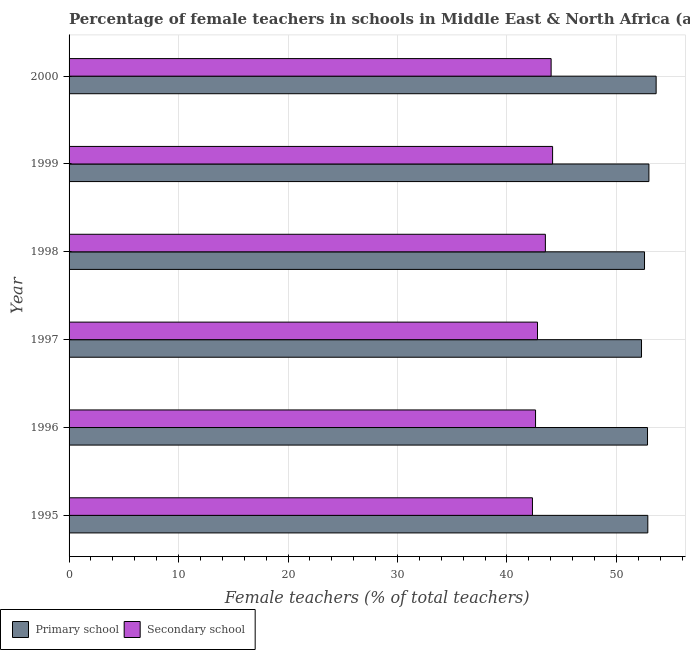Are the number of bars on each tick of the Y-axis equal?
Your answer should be very brief. Yes. What is the label of the 2nd group of bars from the top?
Keep it short and to the point. 1999. In how many cases, is the number of bars for a given year not equal to the number of legend labels?
Provide a short and direct response. 0. What is the percentage of female teachers in secondary schools in 1998?
Keep it short and to the point. 43.51. Across all years, what is the maximum percentage of female teachers in secondary schools?
Ensure brevity in your answer.  44.17. Across all years, what is the minimum percentage of female teachers in primary schools?
Offer a terse response. 52.29. What is the total percentage of female teachers in secondary schools in the graph?
Ensure brevity in your answer.  259.44. What is the difference between the percentage of female teachers in secondary schools in 1996 and that in 2000?
Make the answer very short. -1.42. What is the difference between the percentage of female teachers in primary schools in 1995 and the percentage of female teachers in secondary schools in 1999?
Provide a short and direct response. 8.7. What is the average percentage of female teachers in primary schools per year?
Provide a succinct answer. 52.86. In the year 2000, what is the difference between the percentage of female teachers in primary schools and percentage of female teachers in secondary schools?
Provide a succinct answer. 9.59. Is the difference between the percentage of female teachers in secondary schools in 1998 and 2000 greater than the difference between the percentage of female teachers in primary schools in 1998 and 2000?
Offer a terse response. Yes. What is the difference between the highest and the second highest percentage of female teachers in secondary schools?
Offer a very short reply. 0.13. What is the difference between the highest and the lowest percentage of female teachers in secondary schools?
Give a very brief answer. 1.84. In how many years, is the percentage of female teachers in primary schools greater than the average percentage of female teachers in primary schools taken over all years?
Your answer should be very brief. 3. Is the sum of the percentage of female teachers in primary schools in 1995 and 1997 greater than the maximum percentage of female teachers in secondary schools across all years?
Offer a very short reply. Yes. What does the 1st bar from the top in 1996 represents?
Offer a very short reply. Secondary school. What does the 2nd bar from the bottom in 1999 represents?
Offer a terse response. Secondary school. What is the difference between two consecutive major ticks on the X-axis?
Provide a short and direct response. 10. Does the graph contain grids?
Provide a succinct answer. Yes. What is the title of the graph?
Provide a succinct answer. Percentage of female teachers in schools in Middle East & North Africa (all income levels). What is the label or title of the X-axis?
Keep it short and to the point. Female teachers (% of total teachers). What is the label or title of the Y-axis?
Give a very brief answer. Year. What is the Female teachers (% of total teachers) of Primary school in 1995?
Give a very brief answer. 52.87. What is the Female teachers (% of total teachers) in Secondary school in 1995?
Offer a terse response. 42.33. What is the Female teachers (% of total teachers) in Primary school in 1996?
Provide a short and direct response. 52.84. What is the Female teachers (% of total teachers) in Secondary school in 1996?
Make the answer very short. 42.61. What is the Female teachers (% of total teachers) of Primary school in 1997?
Give a very brief answer. 52.29. What is the Female teachers (% of total teachers) in Secondary school in 1997?
Your answer should be very brief. 42.79. What is the Female teachers (% of total teachers) of Primary school in 1998?
Give a very brief answer. 52.56. What is the Female teachers (% of total teachers) of Secondary school in 1998?
Give a very brief answer. 43.51. What is the Female teachers (% of total teachers) of Primary school in 1999?
Make the answer very short. 52.97. What is the Female teachers (% of total teachers) of Secondary school in 1999?
Provide a short and direct response. 44.17. What is the Female teachers (% of total teachers) of Primary school in 2000?
Give a very brief answer. 53.63. What is the Female teachers (% of total teachers) of Secondary school in 2000?
Offer a very short reply. 44.03. Across all years, what is the maximum Female teachers (% of total teachers) of Primary school?
Ensure brevity in your answer.  53.63. Across all years, what is the maximum Female teachers (% of total teachers) in Secondary school?
Your response must be concise. 44.17. Across all years, what is the minimum Female teachers (% of total teachers) in Primary school?
Your answer should be compact. 52.29. Across all years, what is the minimum Female teachers (% of total teachers) of Secondary school?
Provide a short and direct response. 42.33. What is the total Female teachers (% of total teachers) in Primary school in the graph?
Your answer should be very brief. 317.15. What is the total Female teachers (% of total teachers) of Secondary school in the graph?
Offer a very short reply. 259.44. What is the difference between the Female teachers (% of total teachers) of Primary school in 1995 and that in 1996?
Ensure brevity in your answer.  0.03. What is the difference between the Female teachers (% of total teachers) of Secondary school in 1995 and that in 1996?
Your answer should be compact. -0.28. What is the difference between the Female teachers (% of total teachers) of Primary school in 1995 and that in 1997?
Offer a terse response. 0.58. What is the difference between the Female teachers (% of total teachers) of Secondary school in 1995 and that in 1997?
Your answer should be very brief. -0.46. What is the difference between the Female teachers (% of total teachers) of Primary school in 1995 and that in 1998?
Keep it short and to the point. 0.3. What is the difference between the Female teachers (% of total teachers) of Secondary school in 1995 and that in 1998?
Give a very brief answer. -1.18. What is the difference between the Female teachers (% of total teachers) in Primary school in 1995 and that in 1999?
Provide a short and direct response. -0.1. What is the difference between the Female teachers (% of total teachers) of Secondary school in 1995 and that in 1999?
Provide a succinct answer. -1.84. What is the difference between the Female teachers (% of total teachers) in Primary school in 1995 and that in 2000?
Your answer should be very brief. -0.76. What is the difference between the Female teachers (% of total teachers) of Secondary school in 1995 and that in 2000?
Offer a very short reply. -1.71. What is the difference between the Female teachers (% of total teachers) in Primary school in 1996 and that in 1997?
Make the answer very short. 0.55. What is the difference between the Female teachers (% of total teachers) in Secondary school in 1996 and that in 1997?
Keep it short and to the point. -0.18. What is the difference between the Female teachers (% of total teachers) in Primary school in 1996 and that in 1998?
Your answer should be compact. 0.27. What is the difference between the Female teachers (% of total teachers) of Secondary school in 1996 and that in 1998?
Offer a very short reply. -0.9. What is the difference between the Female teachers (% of total teachers) in Primary school in 1996 and that in 1999?
Provide a succinct answer. -0.13. What is the difference between the Female teachers (% of total teachers) of Secondary school in 1996 and that in 1999?
Make the answer very short. -1.56. What is the difference between the Female teachers (% of total teachers) in Primary school in 1996 and that in 2000?
Ensure brevity in your answer.  -0.79. What is the difference between the Female teachers (% of total teachers) of Secondary school in 1996 and that in 2000?
Your answer should be very brief. -1.42. What is the difference between the Female teachers (% of total teachers) in Primary school in 1997 and that in 1998?
Offer a very short reply. -0.27. What is the difference between the Female teachers (% of total teachers) in Secondary school in 1997 and that in 1998?
Offer a very short reply. -0.72. What is the difference between the Female teachers (% of total teachers) of Primary school in 1997 and that in 1999?
Make the answer very short. -0.68. What is the difference between the Female teachers (% of total teachers) in Secondary school in 1997 and that in 1999?
Provide a short and direct response. -1.38. What is the difference between the Female teachers (% of total teachers) of Primary school in 1997 and that in 2000?
Make the answer very short. -1.34. What is the difference between the Female teachers (% of total teachers) of Secondary school in 1997 and that in 2000?
Make the answer very short. -1.24. What is the difference between the Female teachers (% of total teachers) of Primary school in 1998 and that in 1999?
Provide a succinct answer. -0.4. What is the difference between the Female teachers (% of total teachers) in Secondary school in 1998 and that in 1999?
Keep it short and to the point. -0.66. What is the difference between the Female teachers (% of total teachers) in Primary school in 1998 and that in 2000?
Keep it short and to the point. -1.06. What is the difference between the Female teachers (% of total teachers) of Secondary school in 1998 and that in 2000?
Provide a succinct answer. -0.53. What is the difference between the Female teachers (% of total teachers) of Primary school in 1999 and that in 2000?
Your answer should be compact. -0.66. What is the difference between the Female teachers (% of total teachers) in Secondary school in 1999 and that in 2000?
Keep it short and to the point. 0.13. What is the difference between the Female teachers (% of total teachers) in Primary school in 1995 and the Female teachers (% of total teachers) in Secondary school in 1996?
Make the answer very short. 10.26. What is the difference between the Female teachers (% of total teachers) in Primary school in 1995 and the Female teachers (% of total teachers) in Secondary school in 1997?
Keep it short and to the point. 10.08. What is the difference between the Female teachers (% of total teachers) of Primary school in 1995 and the Female teachers (% of total teachers) of Secondary school in 1998?
Keep it short and to the point. 9.36. What is the difference between the Female teachers (% of total teachers) in Primary school in 1995 and the Female teachers (% of total teachers) in Secondary school in 1999?
Keep it short and to the point. 8.7. What is the difference between the Female teachers (% of total teachers) in Primary school in 1995 and the Female teachers (% of total teachers) in Secondary school in 2000?
Your answer should be compact. 8.83. What is the difference between the Female teachers (% of total teachers) in Primary school in 1996 and the Female teachers (% of total teachers) in Secondary school in 1997?
Give a very brief answer. 10.05. What is the difference between the Female teachers (% of total teachers) in Primary school in 1996 and the Female teachers (% of total teachers) in Secondary school in 1998?
Your answer should be very brief. 9.33. What is the difference between the Female teachers (% of total teachers) in Primary school in 1996 and the Female teachers (% of total teachers) in Secondary school in 1999?
Offer a terse response. 8.67. What is the difference between the Female teachers (% of total teachers) of Primary school in 1996 and the Female teachers (% of total teachers) of Secondary school in 2000?
Your answer should be very brief. 8.8. What is the difference between the Female teachers (% of total teachers) of Primary school in 1997 and the Female teachers (% of total teachers) of Secondary school in 1998?
Ensure brevity in your answer.  8.78. What is the difference between the Female teachers (% of total teachers) of Primary school in 1997 and the Female teachers (% of total teachers) of Secondary school in 1999?
Offer a very short reply. 8.12. What is the difference between the Female teachers (% of total teachers) in Primary school in 1997 and the Female teachers (% of total teachers) in Secondary school in 2000?
Provide a short and direct response. 8.26. What is the difference between the Female teachers (% of total teachers) of Primary school in 1998 and the Female teachers (% of total teachers) of Secondary school in 1999?
Give a very brief answer. 8.4. What is the difference between the Female teachers (% of total teachers) of Primary school in 1998 and the Female teachers (% of total teachers) of Secondary school in 2000?
Ensure brevity in your answer.  8.53. What is the difference between the Female teachers (% of total teachers) in Primary school in 1999 and the Female teachers (% of total teachers) in Secondary school in 2000?
Provide a short and direct response. 8.93. What is the average Female teachers (% of total teachers) of Primary school per year?
Your answer should be very brief. 52.86. What is the average Female teachers (% of total teachers) in Secondary school per year?
Offer a very short reply. 43.24. In the year 1995, what is the difference between the Female teachers (% of total teachers) of Primary school and Female teachers (% of total teachers) of Secondary school?
Your answer should be very brief. 10.54. In the year 1996, what is the difference between the Female teachers (% of total teachers) in Primary school and Female teachers (% of total teachers) in Secondary school?
Keep it short and to the point. 10.23. In the year 1997, what is the difference between the Female teachers (% of total teachers) in Primary school and Female teachers (% of total teachers) in Secondary school?
Offer a very short reply. 9.5. In the year 1998, what is the difference between the Female teachers (% of total teachers) in Primary school and Female teachers (% of total teachers) in Secondary school?
Keep it short and to the point. 9.06. In the year 1999, what is the difference between the Female teachers (% of total teachers) in Primary school and Female teachers (% of total teachers) in Secondary school?
Give a very brief answer. 8.8. In the year 2000, what is the difference between the Female teachers (% of total teachers) of Primary school and Female teachers (% of total teachers) of Secondary school?
Ensure brevity in your answer.  9.59. What is the ratio of the Female teachers (% of total teachers) of Primary school in 1995 to that in 1997?
Make the answer very short. 1.01. What is the ratio of the Female teachers (% of total teachers) in Secondary school in 1995 to that in 1998?
Your response must be concise. 0.97. What is the ratio of the Female teachers (% of total teachers) in Secondary school in 1995 to that in 1999?
Your answer should be very brief. 0.96. What is the ratio of the Female teachers (% of total teachers) in Primary school in 1995 to that in 2000?
Keep it short and to the point. 0.99. What is the ratio of the Female teachers (% of total teachers) of Secondary school in 1995 to that in 2000?
Make the answer very short. 0.96. What is the ratio of the Female teachers (% of total teachers) in Primary school in 1996 to that in 1997?
Keep it short and to the point. 1.01. What is the ratio of the Female teachers (% of total teachers) in Primary school in 1996 to that in 1998?
Provide a short and direct response. 1.01. What is the ratio of the Female teachers (% of total teachers) of Secondary school in 1996 to that in 1998?
Keep it short and to the point. 0.98. What is the ratio of the Female teachers (% of total teachers) in Secondary school in 1996 to that in 1999?
Keep it short and to the point. 0.96. What is the ratio of the Female teachers (% of total teachers) in Secondary school in 1996 to that in 2000?
Your answer should be very brief. 0.97. What is the ratio of the Female teachers (% of total teachers) of Secondary school in 1997 to that in 1998?
Make the answer very short. 0.98. What is the ratio of the Female teachers (% of total teachers) of Primary school in 1997 to that in 1999?
Provide a succinct answer. 0.99. What is the ratio of the Female teachers (% of total teachers) in Secondary school in 1997 to that in 1999?
Your answer should be compact. 0.97. What is the ratio of the Female teachers (% of total teachers) of Primary school in 1997 to that in 2000?
Offer a terse response. 0.98. What is the ratio of the Female teachers (% of total teachers) in Secondary school in 1997 to that in 2000?
Your answer should be very brief. 0.97. What is the ratio of the Female teachers (% of total teachers) in Primary school in 1998 to that in 1999?
Give a very brief answer. 0.99. What is the ratio of the Female teachers (% of total teachers) in Secondary school in 1998 to that in 1999?
Ensure brevity in your answer.  0.99. What is the ratio of the Female teachers (% of total teachers) in Primary school in 1998 to that in 2000?
Your response must be concise. 0.98. What is the ratio of the Female teachers (% of total teachers) of Secondary school in 1998 to that in 2000?
Offer a terse response. 0.99. What is the ratio of the Female teachers (% of total teachers) of Secondary school in 1999 to that in 2000?
Your answer should be compact. 1. What is the difference between the highest and the second highest Female teachers (% of total teachers) of Primary school?
Your answer should be compact. 0.66. What is the difference between the highest and the second highest Female teachers (% of total teachers) in Secondary school?
Your answer should be very brief. 0.13. What is the difference between the highest and the lowest Female teachers (% of total teachers) in Primary school?
Your answer should be compact. 1.34. What is the difference between the highest and the lowest Female teachers (% of total teachers) in Secondary school?
Provide a short and direct response. 1.84. 